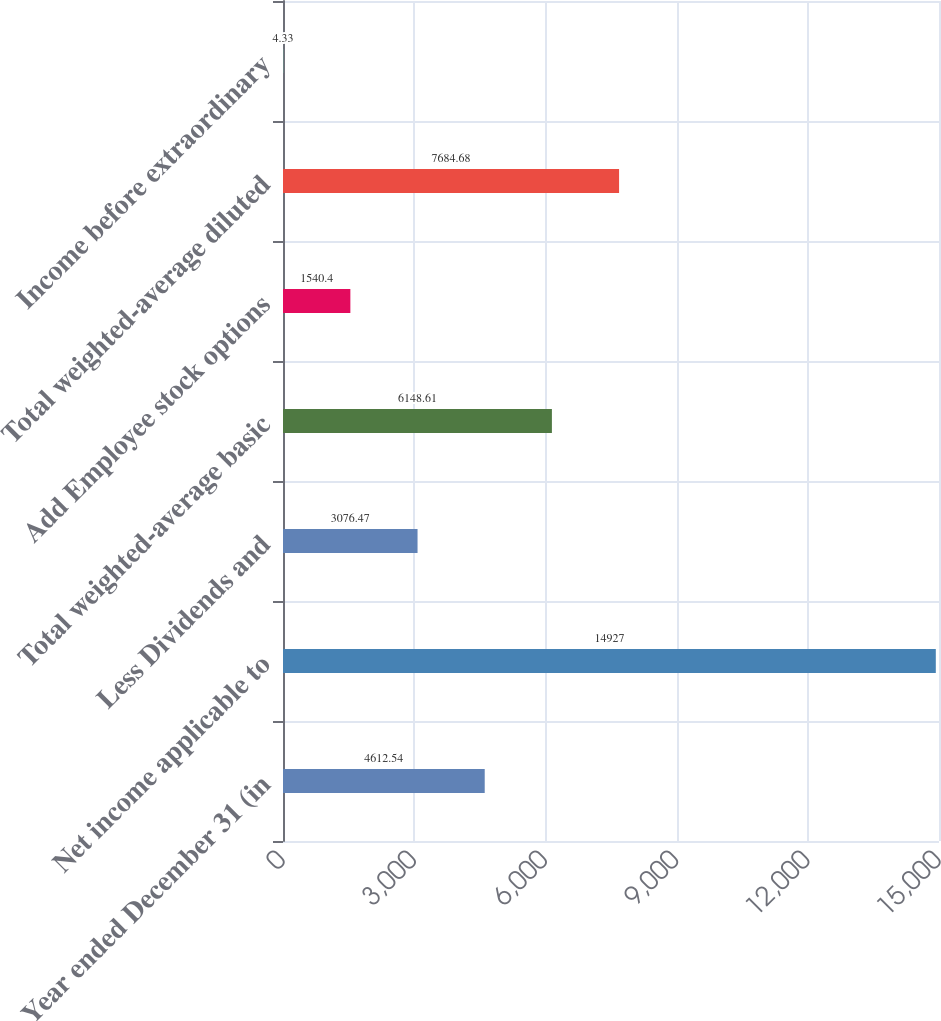Convert chart to OTSL. <chart><loc_0><loc_0><loc_500><loc_500><bar_chart><fcel>Year ended December 31 (in<fcel>Net income applicable to<fcel>Less Dividends and<fcel>Total weighted-average basic<fcel>Add Employee stock options<fcel>Total weighted-average diluted<fcel>Income before extraordinary<nl><fcel>4612.54<fcel>14927<fcel>3076.47<fcel>6148.61<fcel>1540.4<fcel>7684.68<fcel>4.33<nl></chart> 